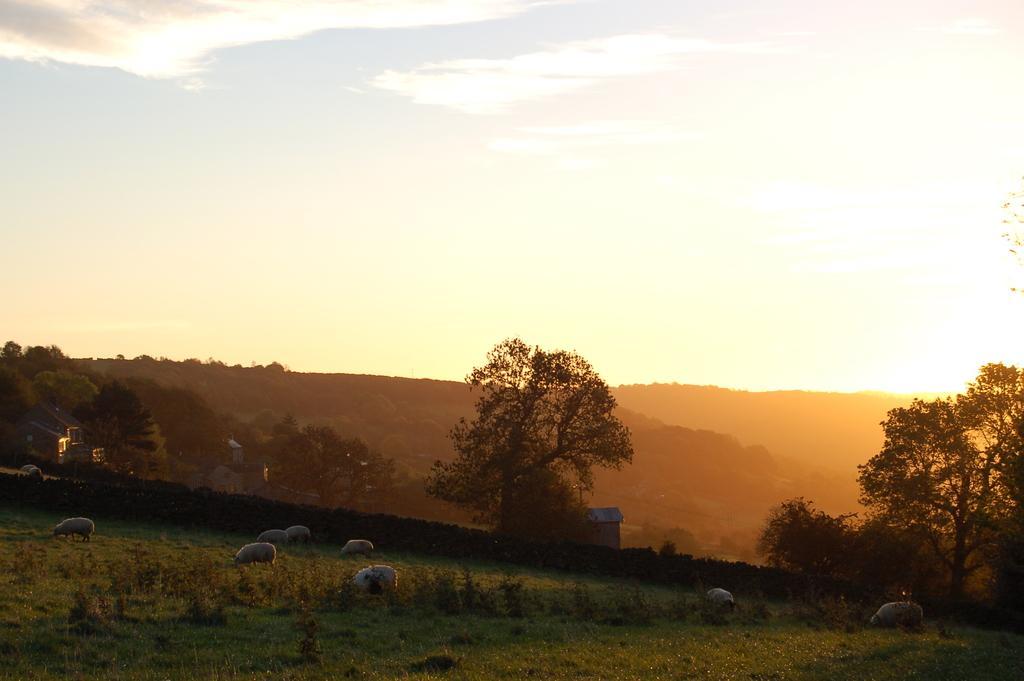Please provide a concise description of this image. At the bottom of the image we can see trees, sheeps, plants and grass. In the background we can see buildings, trees, hills, sky and clouds. 